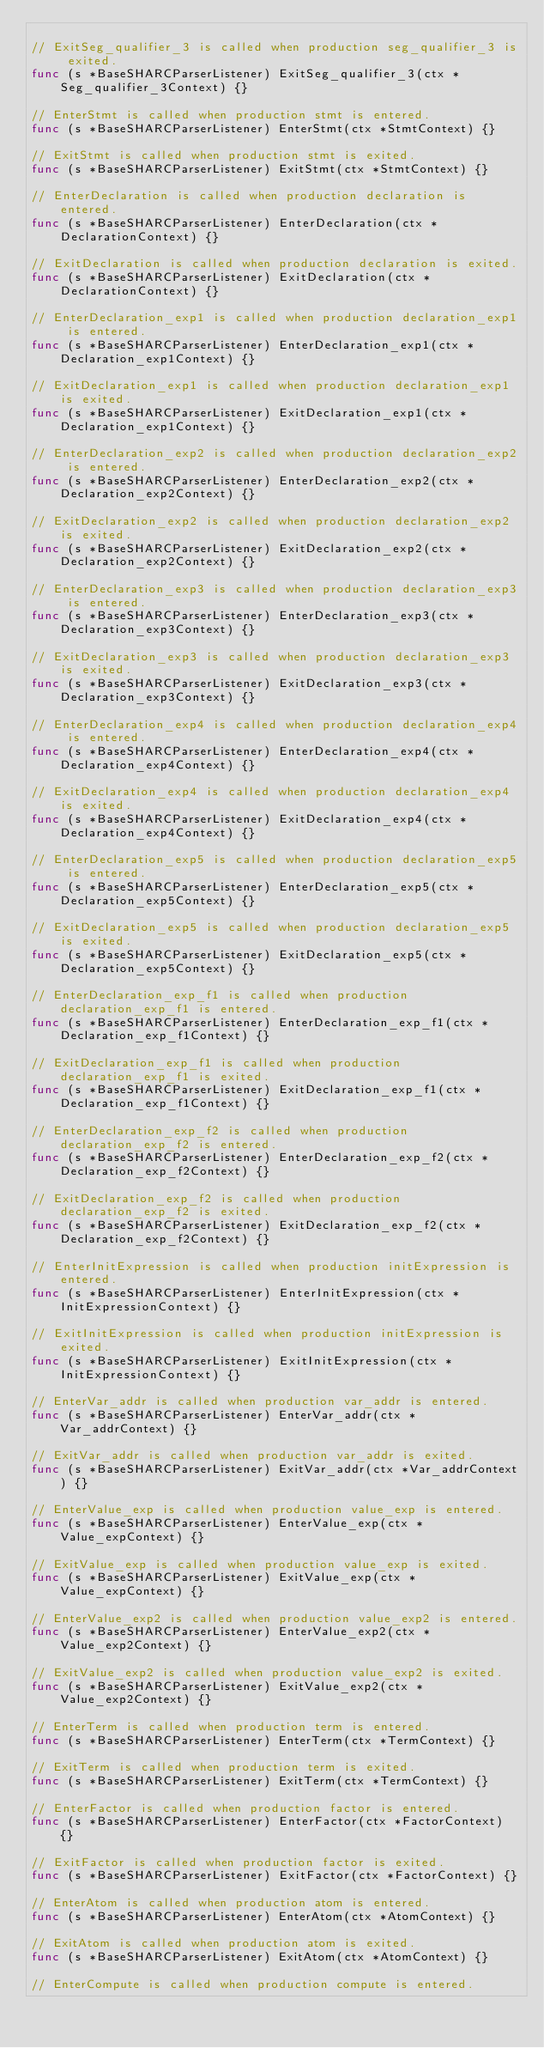Convert code to text. <code><loc_0><loc_0><loc_500><loc_500><_Go_>
// ExitSeg_qualifier_3 is called when production seg_qualifier_3 is exited.
func (s *BaseSHARCParserListener) ExitSeg_qualifier_3(ctx *Seg_qualifier_3Context) {}

// EnterStmt is called when production stmt is entered.
func (s *BaseSHARCParserListener) EnterStmt(ctx *StmtContext) {}

// ExitStmt is called when production stmt is exited.
func (s *BaseSHARCParserListener) ExitStmt(ctx *StmtContext) {}

// EnterDeclaration is called when production declaration is entered.
func (s *BaseSHARCParserListener) EnterDeclaration(ctx *DeclarationContext) {}

// ExitDeclaration is called when production declaration is exited.
func (s *BaseSHARCParserListener) ExitDeclaration(ctx *DeclarationContext) {}

// EnterDeclaration_exp1 is called when production declaration_exp1 is entered.
func (s *BaseSHARCParserListener) EnterDeclaration_exp1(ctx *Declaration_exp1Context) {}

// ExitDeclaration_exp1 is called when production declaration_exp1 is exited.
func (s *BaseSHARCParserListener) ExitDeclaration_exp1(ctx *Declaration_exp1Context) {}

// EnterDeclaration_exp2 is called when production declaration_exp2 is entered.
func (s *BaseSHARCParserListener) EnterDeclaration_exp2(ctx *Declaration_exp2Context) {}

// ExitDeclaration_exp2 is called when production declaration_exp2 is exited.
func (s *BaseSHARCParserListener) ExitDeclaration_exp2(ctx *Declaration_exp2Context) {}

// EnterDeclaration_exp3 is called when production declaration_exp3 is entered.
func (s *BaseSHARCParserListener) EnterDeclaration_exp3(ctx *Declaration_exp3Context) {}

// ExitDeclaration_exp3 is called when production declaration_exp3 is exited.
func (s *BaseSHARCParserListener) ExitDeclaration_exp3(ctx *Declaration_exp3Context) {}

// EnterDeclaration_exp4 is called when production declaration_exp4 is entered.
func (s *BaseSHARCParserListener) EnterDeclaration_exp4(ctx *Declaration_exp4Context) {}

// ExitDeclaration_exp4 is called when production declaration_exp4 is exited.
func (s *BaseSHARCParserListener) ExitDeclaration_exp4(ctx *Declaration_exp4Context) {}

// EnterDeclaration_exp5 is called when production declaration_exp5 is entered.
func (s *BaseSHARCParserListener) EnterDeclaration_exp5(ctx *Declaration_exp5Context) {}

// ExitDeclaration_exp5 is called when production declaration_exp5 is exited.
func (s *BaseSHARCParserListener) ExitDeclaration_exp5(ctx *Declaration_exp5Context) {}

// EnterDeclaration_exp_f1 is called when production declaration_exp_f1 is entered.
func (s *BaseSHARCParserListener) EnterDeclaration_exp_f1(ctx *Declaration_exp_f1Context) {}

// ExitDeclaration_exp_f1 is called when production declaration_exp_f1 is exited.
func (s *BaseSHARCParserListener) ExitDeclaration_exp_f1(ctx *Declaration_exp_f1Context) {}

// EnterDeclaration_exp_f2 is called when production declaration_exp_f2 is entered.
func (s *BaseSHARCParserListener) EnterDeclaration_exp_f2(ctx *Declaration_exp_f2Context) {}

// ExitDeclaration_exp_f2 is called when production declaration_exp_f2 is exited.
func (s *BaseSHARCParserListener) ExitDeclaration_exp_f2(ctx *Declaration_exp_f2Context) {}

// EnterInitExpression is called when production initExpression is entered.
func (s *BaseSHARCParserListener) EnterInitExpression(ctx *InitExpressionContext) {}

// ExitInitExpression is called when production initExpression is exited.
func (s *BaseSHARCParserListener) ExitInitExpression(ctx *InitExpressionContext) {}

// EnterVar_addr is called when production var_addr is entered.
func (s *BaseSHARCParserListener) EnterVar_addr(ctx *Var_addrContext) {}

// ExitVar_addr is called when production var_addr is exited.
func (s *BaseSHARCParserListener) ExitVar_addr(ctx *Var_addrContext) {}

// EnterValue_exp is called when production value_exp is entered.
func (s *BaseSHARCParserListener) EnterValue_exp(ctx *Value_expContext) {}

// ExitValue_exp is called when production value_exp is exited.
func (s *BaseSHARCParserListener) ExitValue_exp(ctx *Value_expContext) {}

// EnterValue_exp2 is called when production value_exp2 is entered.
func (s *BaseSHARCParserListener) EnterValue_exp2(ctx *Value_exp2Context) {}

// ExitValue_exp2 is called when production value_exp2 is exited.
func (s *BaseSHARCParserListener) ExitValue_exp2(ctx *Value_exp2Context) {}

// EnterTerm is called when production term is entered.
func (s *BaseSHARCParserListener) EnterTerm(ctx *TermContext) {}

// ExitTerm is called when production term is exited.
func (s *BaseSHARCParserListener) ExitTerm(ctx *TermContext) {}

// EnterFactor is called when production factor is entered.
func (s *BaseSHARCParserListener) EnterFactor(ctx *FactorContext) {}

// ExitFactor is called when production factor is exited.
func (s *BaseSHARCParserListener) ExitFactor(ctx *FactorContext) {}

// EnterAtom is called when production atom is entered.
func (s *BaseSHARCParserListener) EnterAtom(ctx *AtomContext) {}

// ExitAtom is called when production atom is exited.
func (s *BaseSHARCParserListener) ExitAtom(ctx *AtomContext) {}

// EnterCompute is called when production compute is entered.</code> 